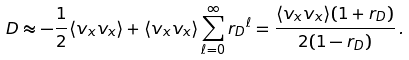Convert formula to latex. <formula><loc_0><loc_0><loc_500><loc_500>D \approx - \frac { 1 } { 2 } \langle v _ { x } v _ { x } \rangle + \langle v _ { x } v _ { x } \rangle \sum _ { \ell = 0 } ^ { \infty } { r _ { D } } ^ { \ell } = \frac { \langle v _ { x } v _ { x } \rangle ( 1 + r _ { D } ) } { 2 ( 1 - r _ { D } ) } \, .</formula> 